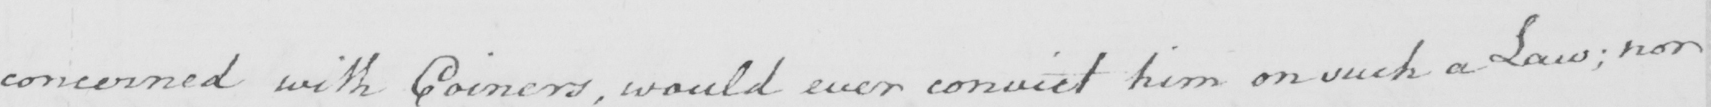Transcribe the text shown in this historical manuscript line. concerned with Coiners , would every convict him on such a Law ; nor 